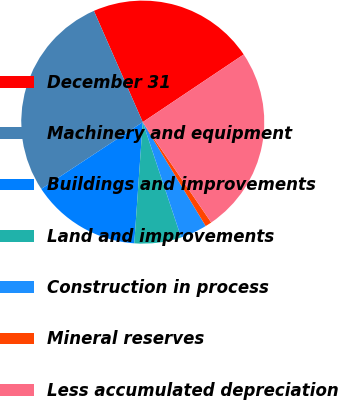<chart> <loc_0><loc_0><loc_500><loc_500><pie_chart><fcel>December 31<fcel>Machinery and equipment<fcel>Buildings and improvements<fcel>Land and improvements<fcel>Construction in process<fcel>Mineral reserves<fcel>Less accumulated depreciation<nl><fcel>22.19%<fcel>27.68%<fcel>14.62%<fcel>6.23%<fcel>3.55%<fcel>0.86%<fcel>24.87%<nl></chart> 